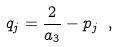Convert formula to latex. <formula><loc_0><loc_0><loc_500><loc_500>q _ { j } = \frac { 2 } { a _ { 3 } } - p _ { j } \ ,</formula> 